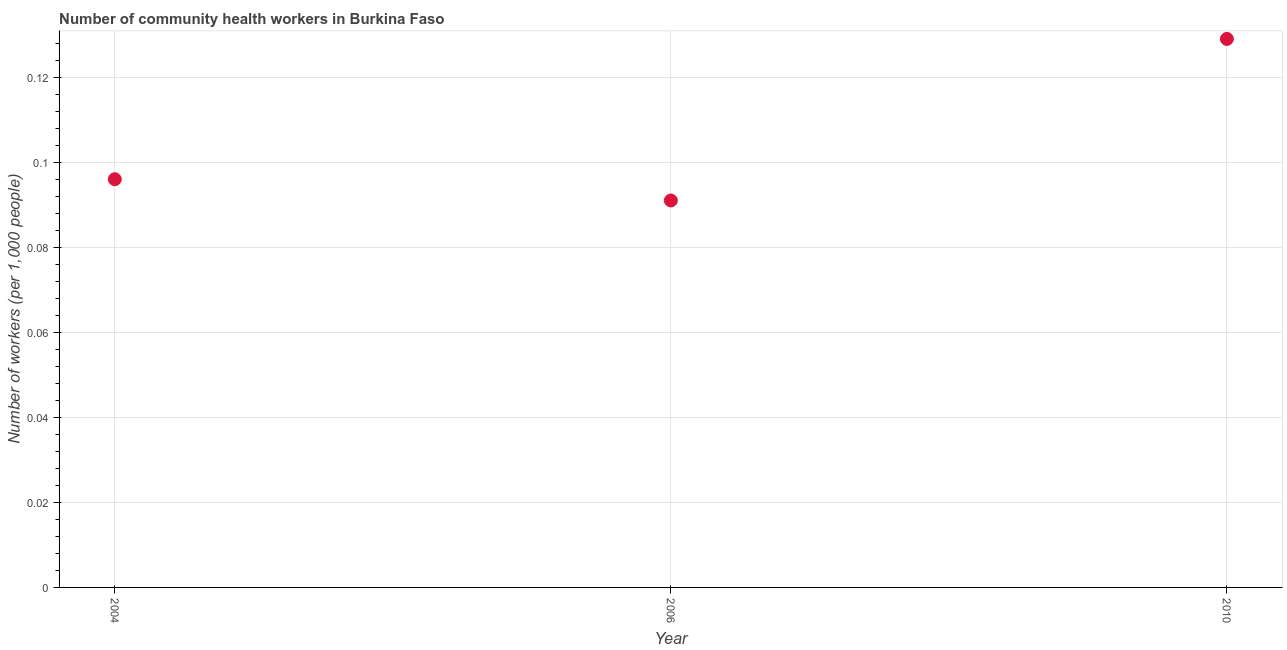What is the number of community health workers in 2006?
Offer a terse response. 0.09. Across all years, what is the maximum number of community health workers?
Give a very brief answer. 0.13. Across all years, what is the minimum number of community health workers?
Provide a succinct answer. 0.09. In which year was the number of community health workers maximum?
Ensure brevity in your answer.  2010. In which year was the number of community health workers minimum?
Your answer should be compact. 2006. What is the sum of the number of community health workers?
Offer a terse response. 0.32. What is the difference between the number of community health workers in 2004 and 2010?
Your response must be concise. -0.03. What is the average number of community health workers per year?
Give a very brief answer. 0.11. What is the median number of community health workers?
Your response must be concise. 0.1. What is the ratio of the number of community health workers in 2004 to that in 2010?
Make the answer very short. 0.74. What is the difference between the highest and the second highest number of community health workers?
Make the answer very short. 0.03. Is the sum of the number of community health workers in 2004 and 2010 greater than the maximum number of community health workers across all years?
Your answer should be compact. Yes. What is the difference between the highest and the lowest number of community health workers?
Ensure brevity in your answer.  0.04. Does the number of community health workers monotonically increase over the years?
Offer a terse response. No. How many years are there in the graph?
Ensure brevity in your answer.  3. Are the values on the major ticks of Y-axis written in scientific E-notation?
Keep it short and to the point. No. What is the title of the graph?
Offer a very short reply. Number of community health workers in Burkina Faso. What is the label or title of the X-axis?
Your response must be concise. Year. What is the label or title of the Y-axis?
Offer a very short reply. Number of workers (per 1,0 people). What is the Number of workers (per 1,000 people) in 2004?
Ensure brevity in your answer.  0.1. What is the Number of workers (per 1,000 people) in 2006?
Make the answer very short. 0.09. What is the Number of workers (per 1,000 people) in 2010?
Keep it short and to the point. 0.13. What is the difference between the Number of workers (per 1,000 people) in 2004 and 2006?
Provide a short and direct response. 0.01. What is the difference between the Number of workers (per 1,000 people) in 2004 and 2010?
Provide a short and direct response. -0.03. What is the difference between the Number of workers (per 1,000 people) in 2006 and 2010?
Provide a short and direct response. -0.04. What is the ratio of the Number of workers (per 1,000 people) in 2004 to that in 2006?
Make the answer very short. 1.05. What is the ratio of the Number of workers (per 1,000 people) in 2004 to that in 2010?
Provide a short and direct response. 0.74. What is the ratio of the Number of workers (per 1,000 people) in 2006 to that in 2010?
Make the answer very short. 0.7. 